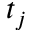<formula> <loc_0><loc_0><loc_500><loc_500>t _ { j }</formula> 